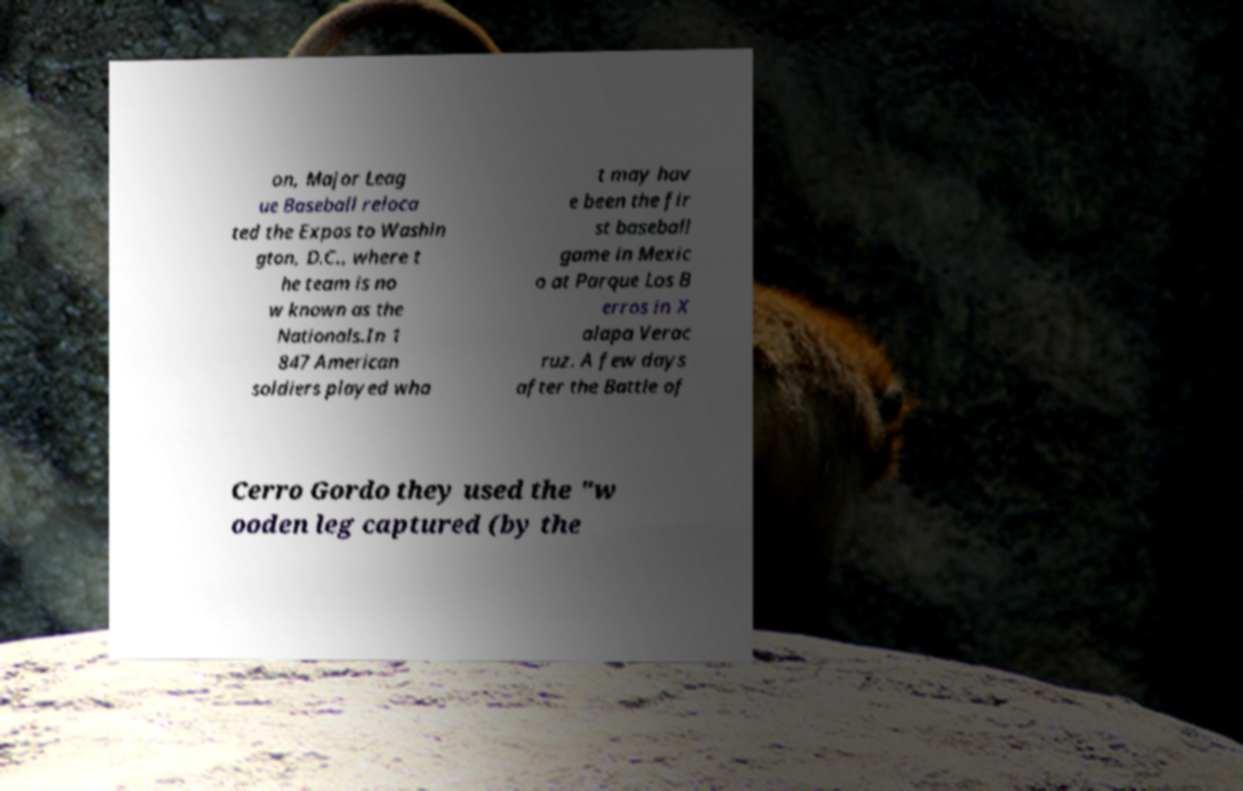There's text embedded in this image that I need extracted. Can you transcribe it verbatim? on, Major Leag ue Baseball reloca ted the Expos to Washin gton, D.C., where t he team is no w known as the Nationals.In 1 847 American soldiers played wha t may hav e been the fir st baseball game in Mexic o at Parque Los B erros in X alapa Verac ruz. A few days after the Battle of Cerro Gordo they used the "w ooden leg captured (by the 